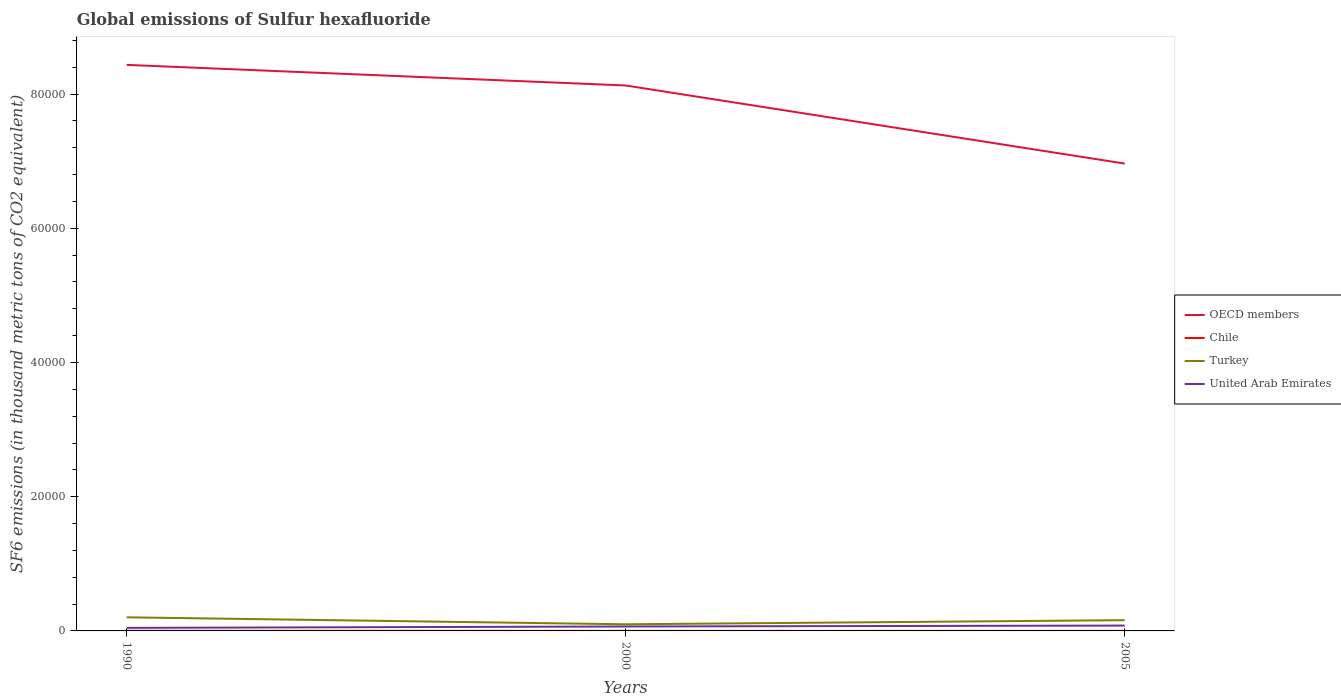How many different coloured lines are there?
Keep it short and to the point. 4. Is the number of lines equal to the number of legend labels?
Provide a short and direct response. Yes. In which year was the global emissions of Sulfur hexafluoride in Turkey maximum?
Offer a very short reply. 2000. What is the total global emissions of Sulfur hexafluoride in Turkey in the graph?
Give a very brief answer. 1037.9. What is the difference between the highest and the second highest global emissions of Sulfur hexafluoride in OECD members?
Your answer should be very brief. 1.47e+04. What is the difference between the highest and the lowest global emissions of Sulfur hexafluoride in United Arab Emirates?
Give a very brief answer. 2. How many years are there in the graph?
Your answer should be very brief. 3. Does the graph contain any zero values?
Ensure brevity in your answer.  No. Does the graph contain grids?
Ensure brevity in your answer.  No. What is the title of the graph?
Your answer should be very brief. Global emissions of Sulfur hexafluoride. Does "Serbia" appear as one of the legend labels in the graph?
Make the answer very short. No. What is the label or title of the X-axis?
Offer a terse response. Years. What is the label or title of the Y-axis?
Give a very brief answer. SF6 emissions (in thousand metric tons of CO2 equivalent). What is the SF6 emissions (in thousand metric tons of CO2 equivalent) in OECD members in 1990?
Your answer should be very brief. 8.44e+04. What is the SF6 emissions (in thousand metric tons of CO2 equivalent) of Chile in 1990?
Offer a very short reply. 16.5. What is the SF6 emissions (in thousand metric tons of CO2 equivalent) of Turkey in 1990?
Make the answer very short. 2027.1. What is the SF6 emissions (in thousand metric tons of CO2 equivalent) in United Arab Emirates in 1990?
Give a very brief answer. 456.1. What is the SF6 emissions (in thousand metric tons of CO2 equivalent) in OECD members in 2000?
Offer a very short reply. 8.13e+04. What is the SF6 emissions (in thousand metric tons of CO2 equivalent) in Turkey in 2000?
Give a very brief answer. 989.2. What is the SF6 emissions (in thousand metric tons of CO2 equivalent) in United Arab Emirates in 2000?
Your answer should be very brief. 660.1. What is the SF6 emissions (in thousand metric tons of CO2 equivalent) in OECD members in 2005?
Your answer should be very brief. 6.96e+04. What is the SF6 emissions (in thousand metric tons of CO2 equivalent) in Turkey in 2005?
Your answer should be compact. 1602.2. What is the SF6 emissions (in thousand metric tons of CO2 equivalent) in United Arab Emirates in 2005?
Your answer should be compact. 796.2. Across all years, what is the maximum SF6 emissions (in thousand metric tons of CO2 equivalent) of OECD members?
Your answer should be compact. 8.44e+04. Across all years, what is the maximum SF6 emissions (in thousand metric tons of CO2 equivalent) in Chile?
Provide a succinct answer. 16.5. Across all years, what is the maximum SF6 emissions (in thousand metric tons of CO2 equivalent) of Turkey?
Your answer should be compact. 2027.1. Across all years, what is the maximum SF6 emissions (in thousand metric tons of CO2 equivalent) of United Arab Emirates?
Give a very brief answer. 796.2. Across all years, what is the minimum SF6 emissions (in thousand metric tons of CO2 equivalent) of OECD members?
Your answer should be very brief. 6.96e+04. Across all years, what is the minimum SF6 emissions (in thousand metric tons of CO2 equivalent) in Chile?
Provide a short and direct response. 6.7. Across all years, what is the minimum SF6 emissions (in thousand metric tons of CO2 equivalent) of Turkey?
Make the answer very short. 989.2. Across all years, what is the minimum SF6 emissions (in thousand metric tons of CO2 equivalent) of United Arab Emirates?
Ensure brevity in your answer.  456.1. What is the total SF6 emissions (in thousand metric tons of CO2 equivalent) in OECD members in the graph?
Your answer should be very brief. 2.35e+05. What is the total SF6 emissions (in thousand metric tons of CO2 equivalent) of Chile in the graph?
Keep it short and to the point. 32.2. What is the total SF6 emissions (in thousand metric tons of CO2 equivalent) of Turkey in the graph?
Make the answer very short. 4618.5. What is the total SF6 emissions (in thousand metric tons of CO2 equivalent) of United Arab Emirates in the graph?
Keep it short and to the point. 1912.4. What is the difference between the SF6 emissions (in thousand metric tons of CO2 equivalent) in OECD members in 1990 and that in 2000?
Provide a short and direct response. 3071.7. What is the difference between the SF6 emissions (in thousand metric tons of CO2 equivalent) of Turkey in 1990 and that in 2000?
Provide a short and direct response. 1037.9. What is the difference between the SF6 emissions (in thousand metric tons of CO2 equivalent) of United Arab Emirates in 1990 and that in 2000?
Your response must be concise. -204. What is the difference between the SF6 emissions (in thousand metric tons of CO2 equivalent) in OECD members in 1990 and that in 2005?
Offer a very short reply. 1.47e+04. What is the difference between the SF6 emissions (in thousand metric tons of CO2 equivalent) of Turkey in 1990 and that in 2005?
Give a very brief answer. 424.9. What is the difference between the SF6 emissions (in thousand metric tons of CO2 equivalent) of United Arab Emirates in 1990 and that in 2005?
Keep it short and to the point. -340.1. What is the difference between the SF6 emissions (in thousand metric tons of CO2 equivalent) of OECD members in 2000 and that in 2005?
Give a very brief answer. 1.16e+04. What is the difference between the SF6 emissions (in thousand metric tons of CO2 equivalent) of Turkey in 2000 and that in 2005?
Offer a terse response. -613. What is the difference between the SF6 emissions (in thousand metric tons of CO2 equivalent) of United Arab Emirates in 2000 and that in 2005?
Provide a short and direct response. -136.1. What is the difference between the SF6 emissions (in thousand metric tons of CO2 equivalent) in OECD members in 1990 and the SF6 emissions (in thousand metric tons of CO2 equivalent) in Chile in 2000?
Give a very brief answer. 8.43e+04. What is the difference between the SF6 emissions (in thousand metric tons of CO2 equivalent) in OECD members in 1990 and the SF6 emissions (in thousand metric tons of CO2 equivalent) in Turkey in 2000?
Make the answer very short. 8.34e+04. What is the difference between the SF6 emissions (in thousand metric tons of CO2 equivalent) of OECD members in 1990 and the SF6 emissions (in thousand metric tons of CO2 equivalent) of United Arab Emirates in 2000?
Give a very brief answer. 8.37e+04. What is the difference between the SF6 emissions (in thousand metric tons of CO2 equivalent) of Chile in 1990 and the SF6 emissions (in thousand metric tons of CO2 equivalent) of Turkey in 2000?
Your response must be concise. -972.7. What is the difference between the SF6 emissions (in thousand metric tons of CO2 equivalent) in Chile in 1990 and the SF6 emissions (in thousand metric tons of CO2 equivalent) in United Arab Emirates in 2000?
Make the answer very short. -643.6. What is the difference between the SF6 emissions (in thousand metric tons of CO2 equivalent) of Turkey in 1990 and the SF6 emissions (in thousand metric tons of CO2 equivalent) of United Arab Emirates in 2000?
Provide a succinct answer. 1367. What is the difference between the SF6 emissions (in thousand metric tons of CO2 equivalent) of OECD members in 1990 and the SF6 emissions (in thousand metric tons of CO2 equivalent) of Chile in 2005?
Give a very brief answer. 8.43e+04. What is the difference between the SF6 emissions (in thousand metric tons of CO2 equivalent) in OECD members in 1990 and the SF6 emissions (in thousand metric tons of CO2 equivalent) in Turkey in 2005?
Offer a terse response. 8.28e+04. What is the difference between the SF6 emissions (in thousand metric tons of CO2 equivalent) of OECD members in 1990 and the SF6 emissions (in thousand metric tons of CO2 equivalent) of United Arab Emirates in 2005?
Give a very brief answer. 8.36e+04. What is the difference between the SF6 emissions (in thousand metric tons of CO2 equivalent) in Chile in 1990 and the SF6 emissions (in thousand metric tons of CO2 equivalent) in Turkey in 2005?
Your response must be concise. -1585.7. What is the difference between the SF6 emissions (in thousand metric tons of CO2 equivalent) of Chile in 1990 and the SF6 emissions (in thousand metric tons of CO2 equivalent) of United Arab Emirates in 2005?
Offer a very short reply. -779.7. What is the difference between the SF6 emissions (in thousand metric tons of CO2 equivalent) of Turkey in 1990 and the SF6 emissions (in thousand metric tons of CO2 equivalent) of United Arab Emirates in 2005?
Provide a succinct answer. 1230.9. What is the difference between the SF6 emissions (in thousand metric tons of CO2 equivalent) in OECD members in 2000 and the SF6 emissions (in thousand metric tons of CO2 equivalent) in Chile in 2005?
Your response must be concise. 8.13e+04. What is the difference between the SF6 emissions (in thousand metric tons of CO2 equivalent) of OECD members in 2000 and the SF6 emissions (in thousand metric tons of CO2 equivalent) of Turkey in 2005?
Your answer should be compact. 7.97e+04. What is the difference between the SF6 emissions (in thousand metric tons of CO2 equivalent) in OECD members in 2000 and the SF6 emissions (in thousand metric tons of CO2 equivalent) in United Arab Emirates in 2005?
Provide a succinct answer. 8.05e+04. What is the difference between the SF6 emissions (in thousand metric tons of CO2 equivalent) of Chile in 2000 and the SF6 emissions (in thousand metric tons of CO2 equivalent) of Turkey in 2005?
Your answer should be compact. -1595.5. What is the difference between the SF6 emissions (in thousand metric tons of CO2 equivalent) in Chile in 2000 and the SF6 emissions (in thousand metric tons of CO2 equivalent) in United Arab Emirates in 2005?
Make the answer very short. -789.5. What is the difference between the SF6 emissions (in thousand metric tons of CO2 equivalent) of Turkey in 2000 and the SF6 emissions (in thousand metric tons of CO2 equivalent) of United Arab Emirates in 2005?
Provide a succinct answer. 193. What is the average SF6 emissions (in thousand metric tons of CO2 equivalent) of OECD members per year?
Your answer should be very brief. 7.84e+04. What is the average SF6 emissions (in thousand metric tons of CO2 equivalent) in Chile per year?
Make the answer very short. 10.73. What is the average SF6 emissions (in thousand metric tons of CO2 equivalent) of Turkey per year?
Your response must be concise. 1539.5. What is the average SF6 emissions (in thousand metric tons of CO2 equivalent) of United Arab Emirates per year?
Your answer should be very brief. 637.47. In the year 1990, what is the difference between the SF6 emissions (in thousand metric tons of CO2 equivalent) in OECD members and SF6 emissions (in thousand metric tons of CO2 equivalent) in Chile?
Give a very brief answer. 8.43e+04. In the year 1990, what is the difference between the SF6 emissions (in thousand metric tons of CO2 equivalent) of OECD members and SF6 emissions (in thousand metric tons of CO2 equivalent) of Turkey?
Your answer should be very brief. 8.23e+04. In the year 1990, what is the difference between the SF6 emissions (in thousand metric tons of CO2 equivalent) in OECD members and SF6 emissions (in thousand metric tons of CO2 equivalent) in United Arab Emirates?
Offer a terse response. 8.39e+04. In the year 1990, what is the difference between the SF6 emissions (in thousand metric tons of CO2 equivalent) in Chile and SF6 emissions (in thousand metric tons of CO2 equivalent) in Turkey?
Provide a succinct answer. -2010.6. In the year 1990, what is the difference between the SF6 emissions (in thousand metric tons of CO2 equivalent) in Chile and SF6 emissions (in thousand metric tons of CO2 equivalent) in United Arab Emirates?
Make the answer very short. -439.6. In the year 1990, what is the difference between the SF6 emissions (in thousand metric tons of CO2 equivalent) in Turkey and SF6 emissions (in thousand metric tons of CO2 equivalent) in United Arab Emirates?
Your response must be concise. 1571. In the year 2000, what is the difference between the SF6 emissions (in thousand metric tons of CO2 equivalent) in OECD members and SF6 emissions (in thousand metric tons of CO2 equivalent) in Chile?
Offer a terse response. 8.13e+04. In the year 2000, what is the difference between the SF6 emissions (in thousand metric tons of CO2 equivalent) in OECD members and SF6 emissions (in thousand metric tons of CO2 equivalent) in Turkey?
Provide a short and direct response. 8.03e+04. In the year 2000, what is the difference between the SF6 emissions (in thousand metric tons of CO2 equivalent) of OECD members and SF6 emissions (in thousand metric tons of CO2 equivalent) of United Arab Emirates?
Ensure brevity in your answer.  8.06e+04. In the year 2000, what is the difference between the SF6 emissions (in thousand metric tons of CO2 equivalent) in Chile and SF6 emissions (in thousand metric tons of CO2 equivalent) in Turkey?
Your answer should be very brief. -982.5. In the year 2000, what is the difference between the SF6 emissions (in thousand metric tons of CO2 equivalent) in Chile and SF6 emissions (in thousand metric tons of CO2 equivalent) in United Arab Emirates?
Make the answer very short. -653.4. In the year 2000, what is the difference between the SF6 emissions (in thousand metric tons of CO2 equivalent) in Turkey and SF6 emissions (in thousand metric tons of CO2 equivalent) in United Arab Emirates?
Ensure brevity in your answer.  329.1. In the year 2005, what is the difference between the SF6 emissions (in thousand metric tons of CO2 equivalent) in OECD members and SF6 emissions (in thousand metric tons of CO2 equivalent) in Chile?
Offer a terse response. 6.96e+04. In the year 2005, what is the difference between the SF6 emissions (in thousand metric tons of CO2 equivalent) in OECD members and SF6 emissions (in thousand metric tons of CO2 equivalent) in Turkey?
Keep it short and to the point. 6.80e+04. In the year 2005, what is the difference between the SF6 emissions (in thousand metric tons of CO2 equivalent) in OECD members and SF6 emissions (in thousand metric tons of CO2 equivalent) in United Arab Emirates?
Give a very brief answer. 6.88e+04. In the year 2005, what is the difference between the SF6 emissions (in thousand metric tons of CO2 equivalent) in Chile and SF6 emissions (in thousand metric tons of CO2 equivalent) in Turkey?
Offer a terse response. -1593.2. In the year 2005, what is the difference between the SF6 emissions (in thousand metric tons of CO2 equivalent) of Chile and SF6 emissions (in thousand metric tons of CO2 equivalent) of United Arab Emirates?
Ensure brevity in your answer.  -787.2. In the year 2005, what is the difference between the SF6 emissions (in thousand metric tons of CO2 equivalent) of Turkey and SF6 emissions (in thousand metric tons of CO2 equivalent) of United Arab Emirates?
Offer a very short reply. 806. What is the ratio of the SF6 emissions (in thousand metric tons of CO2 equivalent) in OECD members in 1990 to that in 2000?
Your response must be concise. 1.04. What is the ratio of the SF6 emissions (in thousand metric tons of CO2 equivalent) in Chile in 1990 to that in 2000?
Provide a short and direct response. 2.46. What is the ratio of the SF6 emissions (in thousand metric tons of CO2 equivalent) in Turkey in 1990 to that in 2000?
Offer a very short reply. 2.05. What is the ratio of the SF6 emissions (in thousand metric tons of CO2 equivalent) of United Arab Emirates in 1990 to that in 2000?
Offer a very short reply. 0.69. What is the ratio of the SF6 emissions (in thousand metric tons of CO2 equivalent) in OECD members in 1990 to that in 2005?
Provide a short and direct response. 1.21. What is the ratio of the SF6 emissions (in thousand metric tons of CO2 equivalent) of Chile in 1990 to that in 2005?
Your answer should be very brief. 1.83. What is the ratio of the SF6 emissions (in thousand metric tons of CO2 equivalent) in Turkey in 1990 to that in 2005?
Give a very brief answer. 1.27. What is the ratio of the SF6 emissions (in thousand metric tons of CO2 equivalent) of United Arab Emirates in 1990 to that in 2005?
Make the answer very short. 0.57. What is the ratio of the SF6 emissions (in thousand metric tons of CO2 equivalent) of OECD members in 2000 to that in 2005?
Your answer should be very brief. 1.17. What is the ratio of the SF6 emissions (in thousand metric tons of CO2 equivalent) in Chile in 2000 to that in 2005?
Provide a succinct answer. 0.74. What is the ratio of the SF6 emissions (in thousand metric tons of CO2 equivalent) in Turkey in 2000 to that in 2005?
Provide a short and direct response. 0.62. What is the ratio of the SF6 emissions (in thousand metric tons of CO2 equivalent) in United Arab Emirates in 2000 to that in 2005?
Your response must be concise. 0.83. What is the difference between the highest and the second highest SF6 emissions (in thousand metric tons of CO2 equivalent) of OECD members?
Give a very brief answer. 3071.7. What is the difference between the highest and the second highest SF6 emissions (in thousand metric tons of CO2 equivalent) of Turkey?
Provide a short and direct response. 424.9. What is the difference between the highest and the second highest SF6 emissions (in thousand metric tons of CO2 equivalent) of United Arab Emirates?
Your answer should be very brief. 136.1. What is the difference between the highest and the lowest SF6 emissions (in thousand metric tons of CO2 equivalent) of OECD members?
Ensure brevity in your answer.  1.47e+04. What is the difference between the highest and the lowest SF6 emissions (in thousand metric tons of CO2 equivalent) of Turkey?
Offer a very short reply. 1037.9. What is the difference between the highest and the lowest SF6 emissions (in thousand metric tons of CO2 equivalent) of United Arab Emirates?
Provide a succinct answer. 340.1. 